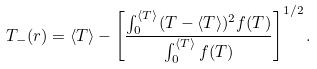Convert formula to latex. <formula><loc_0><loc_0><loc_500><loc_500>T _ { - } ( r ) = \langle T \rangle - \left [ \frac { \int _ { 0 } ^ { \langle T \rangle } ( T - \langle T \rangle ) ^ { 2 } f ( T ) } { \int _ { 0 } ^ { \langle T \rangle } f ( T ) } \right ] ^ { 1 / 2 } .</formula> 